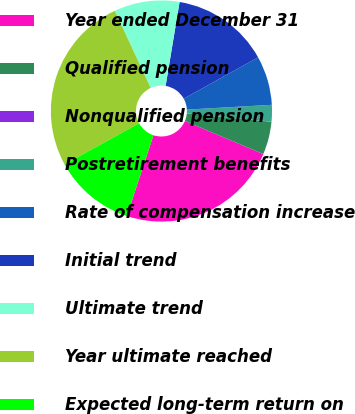Convert chart to OTSL. <chart><loc_0><loc_0><loc_500><loc_500><pie_chart><fcel>Year ended December 31<fcel>Qualified pension<fcel>Nonqualified pension<fcel>Postretirement benefits<fcel>Rate of compensation increase<fcel>Initial trend<fcel>Ultimate trend<fcel>Year ultimate reached<fcel>Expected long-term return on<nl><fcel>23.7%<fcel>4.8%<fcel>0.04%<fcel>2.42%<fcel>7.17%<fcel>14.31%<fcel>9.55%<fcel>26.08%<fcel>11.93%<nl></chart> 